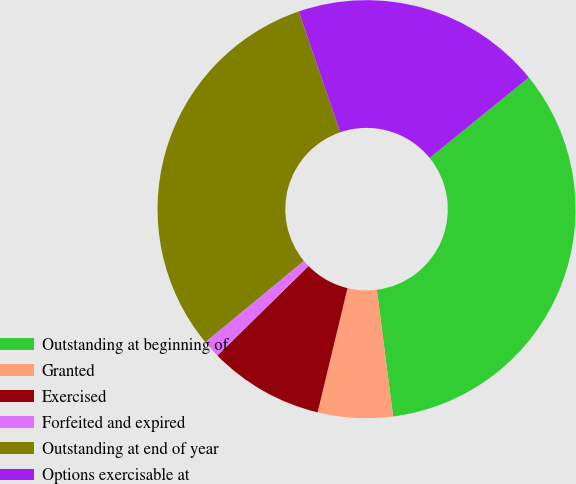Convert chart. <chart><loc_0><loc_0><loc_500><loc_500><pie_chart><fcel>Outstanding at beginning of<fcel>Granted<fcel>Exercised<fcel>Forfeited and expired<fcel>Outstanding at end of year<fcel>Options exercisable at<nl><fcel>33.82%<fcel>5.79%<fcel>8.89%<fcel>1.37%<fcel>30.72%<fcel>19.41%<nl></chart> 